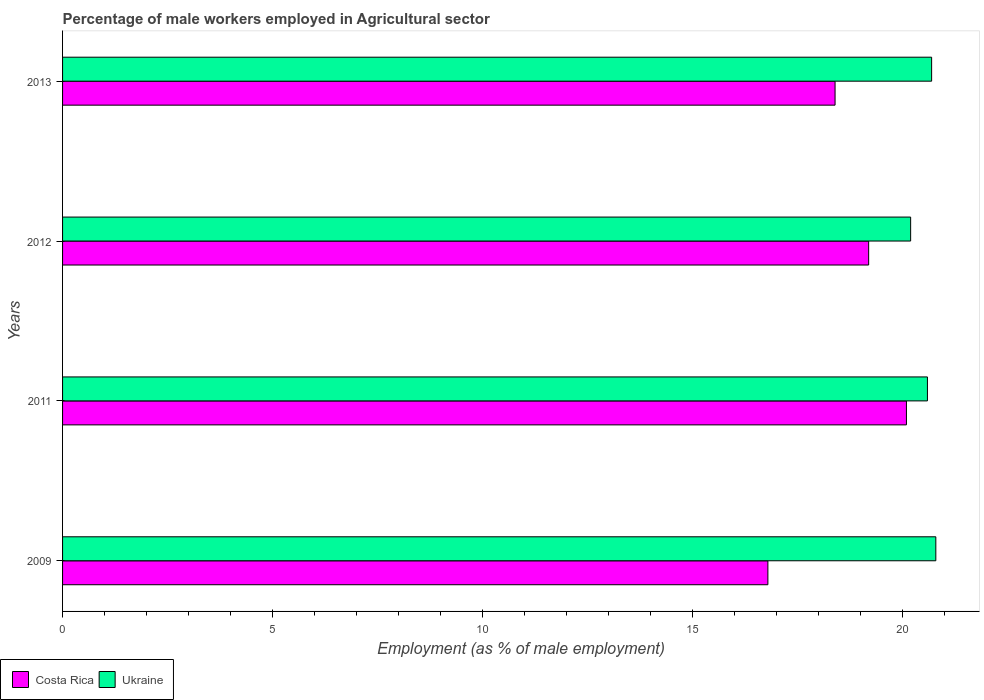Are the number of bars per tick equal to the number of legend labels?
Provide a succinct answer. Yes. Are the number of bars on each tick of the Y-axis equal?
Keep it short and to the point. Yes. How many bars are there on the 3rd tick from the top?
Your response must be concise. 2. How many bars are there on the 3rd tick from the bottom?
Offer a terse response. 2. In how many cases, is the number of bars for a given year not equal to the number of legend labels?
Give a very brief answer. 0. What is the percentage of male workers employed in Agricultural sector in Ukraine in 2009?
Make the answer very short. 20.8. Across all years, what is the maximum percentage of male workers employed in Agricultural sector in Ukraine?
Make the answer very short. 20.8. Across all years, what is the minimum percentage of male workers employed in Agricultural sector in Costa Rica?
Provide a succinct answer. 16.8. In which year was the percentage of male workers employed in Agricultural sector in Costa Rica maximum?
Provide a short and direct response. 2011. In which year was the percentage of male workers employed in Agricultural sector in Costa Rica minimum?
Give a very brief answer. 2009. What is the total percentage of male workers employed in Agricultural sector in Ukraine in the graph?
Your answer should be very brief. 82.3. What is the difference between the percentage of male workers employed in Agricultural sector in Ukraine in 2009 and that in 2013?
Offer a terse response. 0.1. What is the difference between the percentage of male workers employed in Agricultural sector in Costa Rica in 2011 and the percentage of male workers employed in Agricultural sector in Ukraine in 2013?
Ensure brevity in your answer.  -0.6. What is the average percentage of male workers employed in Agricultural sector in Costa Rica per year?
Make the answer very short. 18.62. In the year 2013, what is the difference between the percentage of male workers employed in Agricultural sector in Costa Rica and percentage of male workers employed in Agricultural sector in Ukraine?
Keep it short and to the point. -2.3. In how many years, is the percentage of male workers employed in Agricultural sector in Costa Rica greater than 6 %?
Give a very brief answer. 4. What is the ratio of the percentage of male workers employed in Agricultural sector in Costa Rica in 2009 to that in 2013?
Make the answer very short. 0.91. What is the difference between the highest and the second highest percentage of male workers employed in Agricultural sector in Ukraine?
Provide a short and direct response. 0.1. What is the difference between the highest and the lowest percentage of male workers employed in Agricultural sector in Costa Rica?
Provide a succinct answer. 3.3. Is the sum of the percentage of male workers employed in Agricultural sector in Ukraine in 2011 and 2012 greater than the maximum percentage of male workers employed in Agricultural sector in Costa Rica across all years?
Your answer should be compact. Yes. What does the 1st bar from the bottom in 2011 represents?
Offer a very short reply. Costa Rica. How many bars are there?
Ensure brevity in your answer.  8. What is the difference between two consecutive major ticks on the X-axis?
Your response must be concise. 5. Does the graph contain any zero values?
Your response must be concise. No. Does the graph contain grids?
Make the answer very short. No. How many legend labels are there?
Ensure brevity in your answer.  2. What is the title of the graph?
Offer a very short reply. Percentage of male workers employed in Agricultural sector. Does "Ethiopia" appear as one of the legend labels in the graph?
Your response must be concise. No. What is the label or title of the X-axis?
Offer a very short reply. Employment (as % of male employment). What is the Employment (as % of male employment) in Costa Rica in 2009?
Your answer should be very brief. 16.8. What is the Employment (as % of male employment) in Ukraine in 2009?
Provide a succinct answer. 20.8. What is the Employment (as % of male employment) in Costa Rica in 2011?
Your answer should be compact. 20.1. What is the Employment (as % of male employment) in Ukraine in 2011?
Make the answer very short. 20.6. What is the Employment (as % of male employment) of Costa Rica in 2012?
Make the answer very short. 19.2. What is the Employment (as % of male employment) in Ukraine in 2012?
Offer a terse response. 20.2. What is the Employment (as % of male employment) of Costa Rica in 2013?
Keep it short and to the point. 18.4. What is the Employment (as % of male employment) of Ukraine in 2013?
Your response must be concise. 20.7. Across all years, what is the maximum Employment (as % of male employment) of Costa Rica?
Your answer should be compact. 20.1. Across all years, what is the maximum Employment (as % of male employment) in Ukraine?
Offer a terse response. 20.8. Across all years, what is the minimum Employment (as % of male employment) in Costa Rica?
Your answer should be very brief. 16.8. Across all years, what is the minimum Employment (as % of male employment) of Ukraine?
Offer a terse response. 20.2. What is the total Employment (as % of male employment) in Costa Rica in the graph?
Make the answer very short. 74.5. What is the total Employment (as % of male employment) in Ukraine in the graph?
Provide a succinct answer. 82.3. What is the difference between the Employment (as % of male employment) in Costa Rica in 2009 and that in 2011?
Offer a very short reply. -3.3. What is the difference between the Employment (as % of male employment) in Ukraine in 2009 and that in 2012?
Your response must be concise. 0.6. What is the difference between the Employment (as % of male employment) in Costa Rica in 2009 and that in 2013?
Your response must be concise. -1.6. What is the difference between the Employment (as % of male employment) of Ukraine in 2011 and that in 2013?
Give a very brief answer. -0.1. What is the difference between the Employment (as % of male employment) of Costa Rica in 2012 and that in 2013?
Keep it short and to the point. 0.8. What is the difference between the Employment (as % of male employment) in Costa Rica in 2009 and the Employment (as % of male employment) in Ukraine in 2012?
Your response must be concise. -3.4. What is the difference between the Employment (as % of male employment) of Costa Rica in 2009 and the Employment (as % of male employment) of Ukraine in 2013?
Ensure brevity in your answer.  -3.9. What is the difference between the Employment (as % of male employment) of Costa Rica in 2011 and the Employment (as % of male employment) of Ukraine in 2013?
Ensure brevity in your answer.  -0.6. What is the difference between the Employment (as % of male employment) of Costa Rica in 2012 and the Employment (as % of male employment) of Ukraine in 2013?
Give a very brief answer. -1.5. What is the average Employment (as % of male employment) of Costa Rica per year?
Ensure brevity in your answer.  18.62. What is the average Employment (as % of male employment) of Ukraine per year?
Offer a very short reply. 20.57. In the year 2009, what is the difference between the Employment (as % of male employment) of Costa Rica and Employment (as % of male employment) of Ukraine?
Provide a succinct answer. -4. In the year 2012, what is the difference between the Employment (as % of male employment) in Costa Rica and Employment (as % of male employment) in Ukraine?
Your answer should be very brief. -1. What is the ratio of the Employment (as % of male employment) of Costa Rica in 2009 to that in 2011?
Your answer should be compact. 0.84. What is the ratio of the Employment (as % of male employment) in Ukraine in 2009 to that in 2011?
Offer a very short reply. 1.01. What is the ratio of the Employment (as % of male employment) of Ukraine in 2009 to that in 2012?
Make the answer very short. 1.03. What is the ratio of the Employment (as % of male employment) in Costa Rica in 2009 to that in 2013?
Your answer should be compact. 0.91. What is the ratio of the Employment (as % of male employment) of Costa Rica in 2011 to that in 2012?
Offer a very short reply. 1.05. What is the ratio of the Employment (as % of male employment) in Ukraine in 2011 to that in 2012?
Make the answer very short. 1.02. What is the ratio of the Employment (as % of male employment) in Costa Rica in 2011 to that in 2013?
Give a very brief answer. 1.09. What is the ratio of the Employment (as % of male employment) in Costa Rica in 2012 to that in 2013?
Offer a terse response. 1.04. What is the ratio of the Employment (as % of male employment) in Ukraine in 2012 to that in 2013?
Offer a very short reply. 0.98. What is the difference between the highest and the second highest Employment (as % of male employment) in Costa Rica?
Keep it short and to the point. 0.9. What is the difference between the highest and the second highest Employment (as % of male employment) of Ukraine?
Ensure brevity in your answer.  0.1. What is the difference between the highest and the lowest Employment (as % of male employment) of Ukraine?
Offer a very short reply. 0.6. 